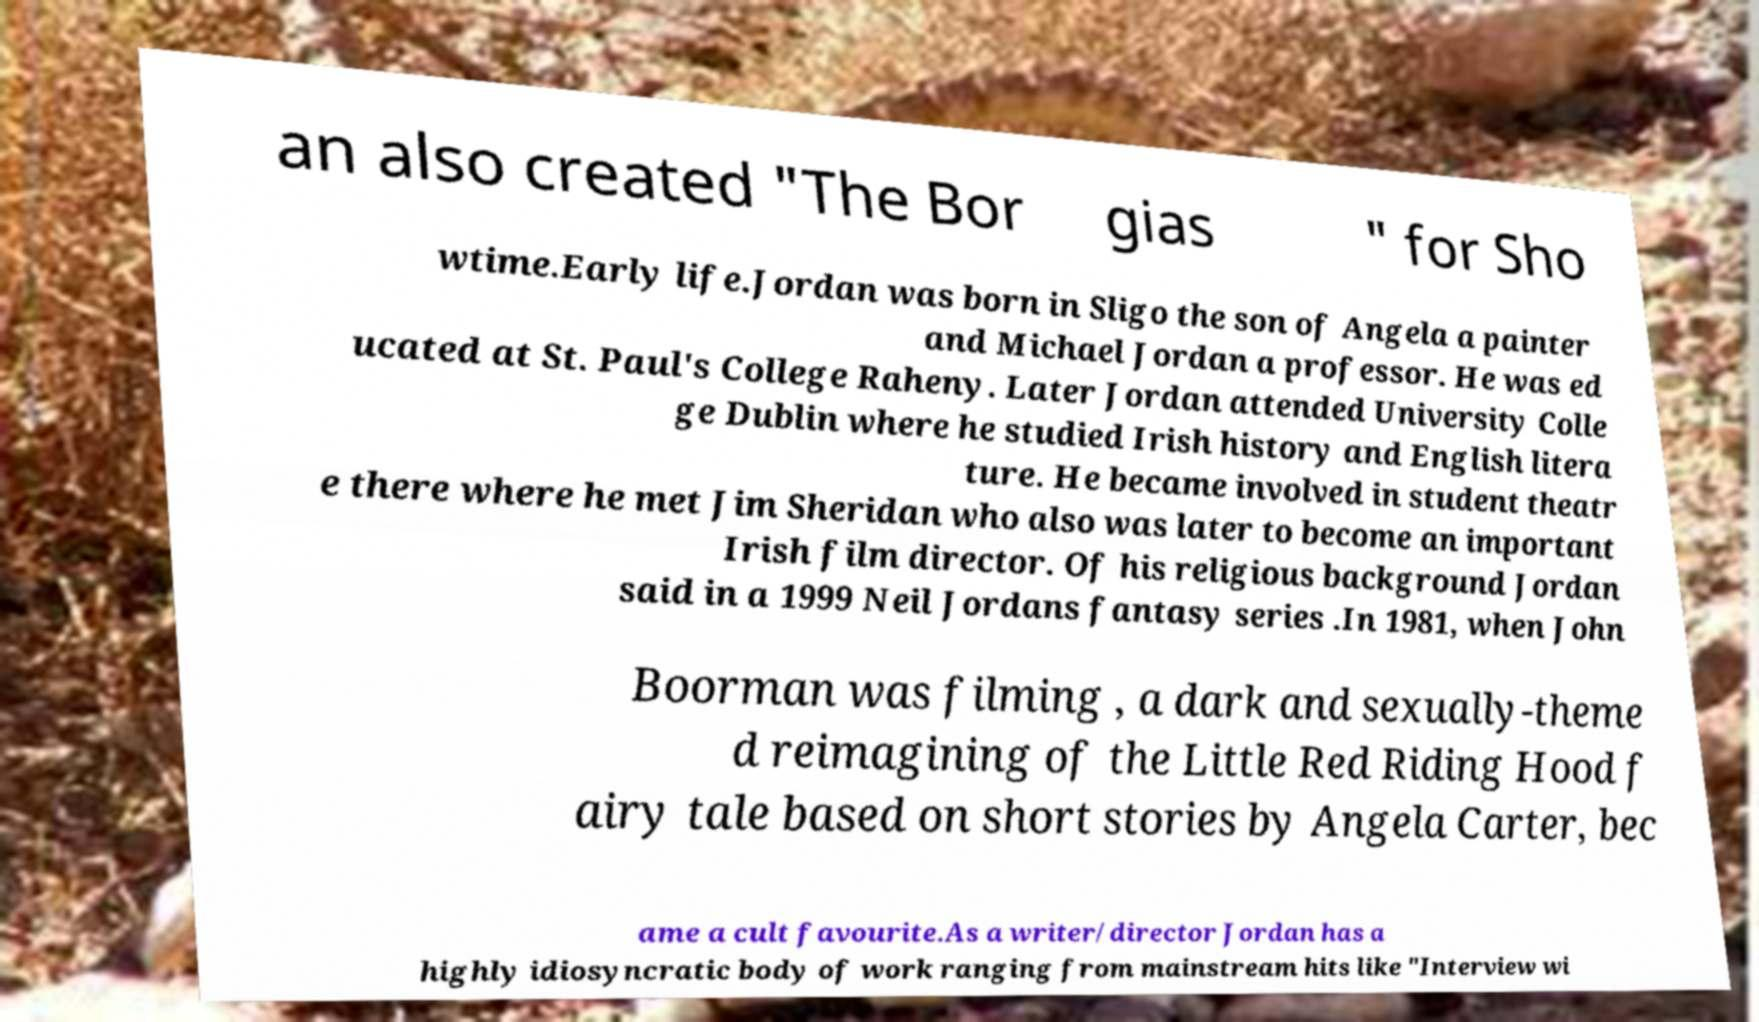There's text embedded in this image that I need extracted. Can you transcribe it verbatim? an also created "The Bor gias " for Sho wtime.Early life.Jordan was born in Sligo the son of Angela a painter and Michael Jordan a professor. He was ed ucated at St. Paul's College Raheny. Later Jordan attended University Colle ge Dublin where he studied Irish history and English litera ture. He became involved in student theatr e there where he met Jim Sheridan who also was later to become an important Irish film director. Of his religious background Jordan said in a 1999 Neil Jordans fantasy series .In 1981, when John Boorman was filming , a dark and sexually-theme d reimagining of the Little Red Riding Hood f airy tale based on short stories by Angela Carter, bec ame a cult favourite.As a writer/director Jordan has a highly idiosyncratic body of work ranging from mainstream hits like "Interview wi 